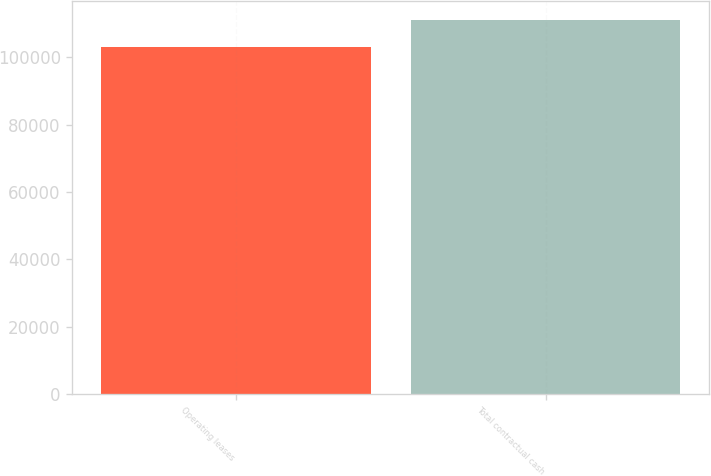<chart> <loc_0><loc_0><loc_500><loc_500><bar_chart><fcel>Operating leases<fcel>Total contractual cash<nl><fcel>103242<fcel>111182<nl></chart> 